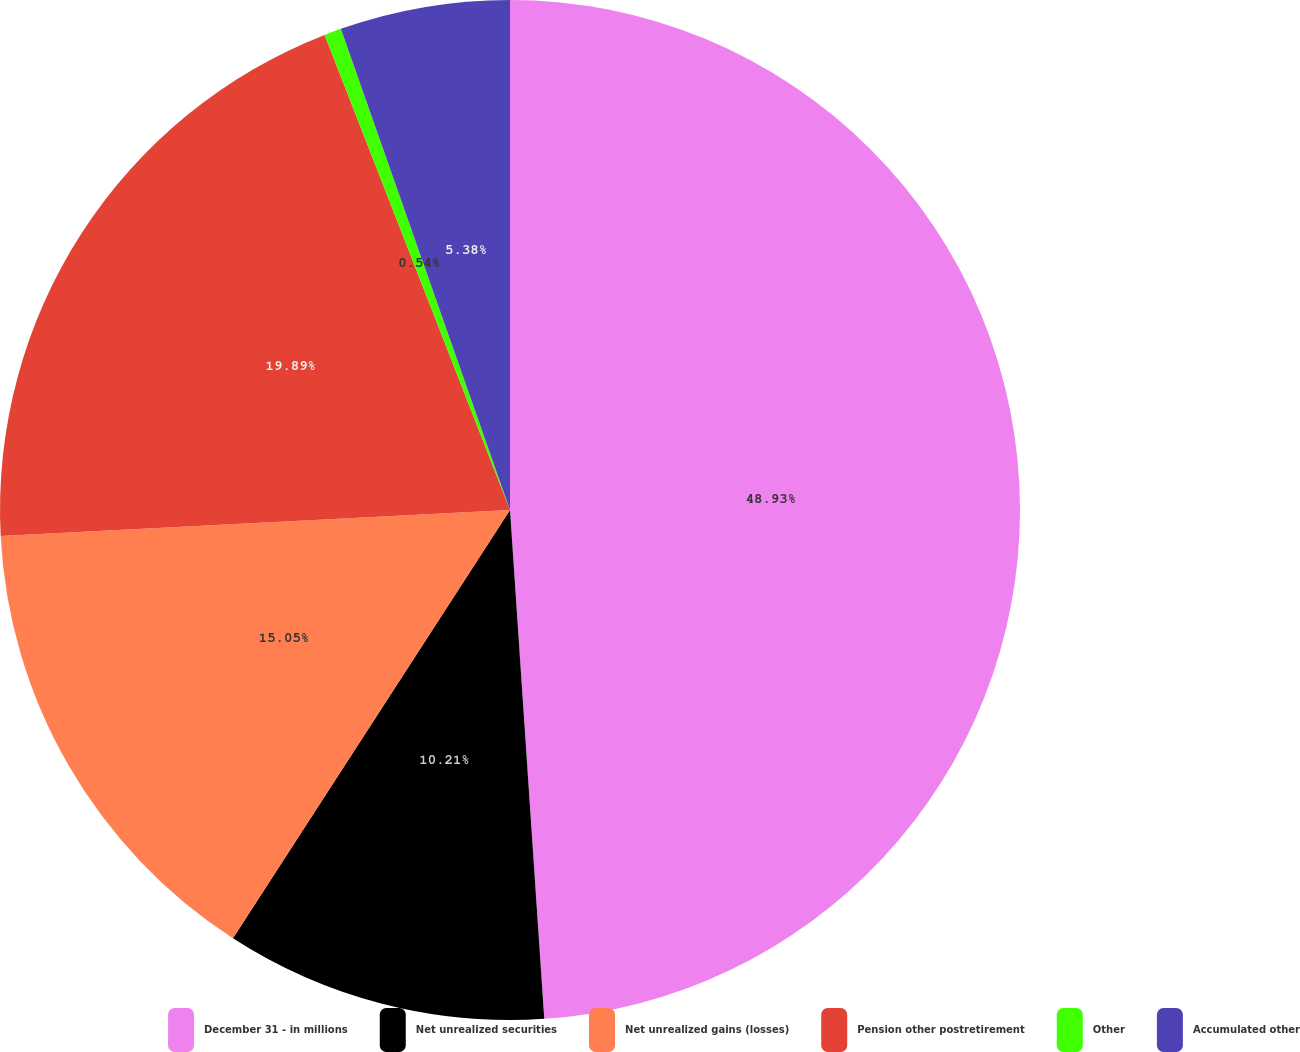<chart> <loc_0><loc_0><loc_500><loc_500><pie_chart><fcel>December 31 - in millions<fcel>Net unrealized securities<fcel>Net unrealized gains (losses)<fcel>Pension other postretirement<fcel>Other<fcel>Accumulated other<nl><fcel>48.93%<fcel>10.21%<fcel>15.05%<fcel>19.89%<fcel>0.54%<fcel>5.38%<nl></chart> 